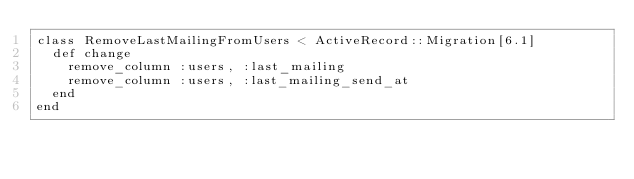<code> <loc_0><loc_0><loc_500><loc_500><_Ruby_>class RemoveLastMailingFromUsers < ActiveRecord::Migration[6.1]
  def change
    remove_column :users, :last_mailing
    remove_column :users, :last_mailing_send_at 
  end
end
</code> 